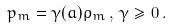Convert formula to latex. <formula><loc_0><loc_0><loc_500><loc_500>p _ { m } = \gamma ( a ) \rho _ { m } \, , \, \gamma \geq 0 \, .</formula> 